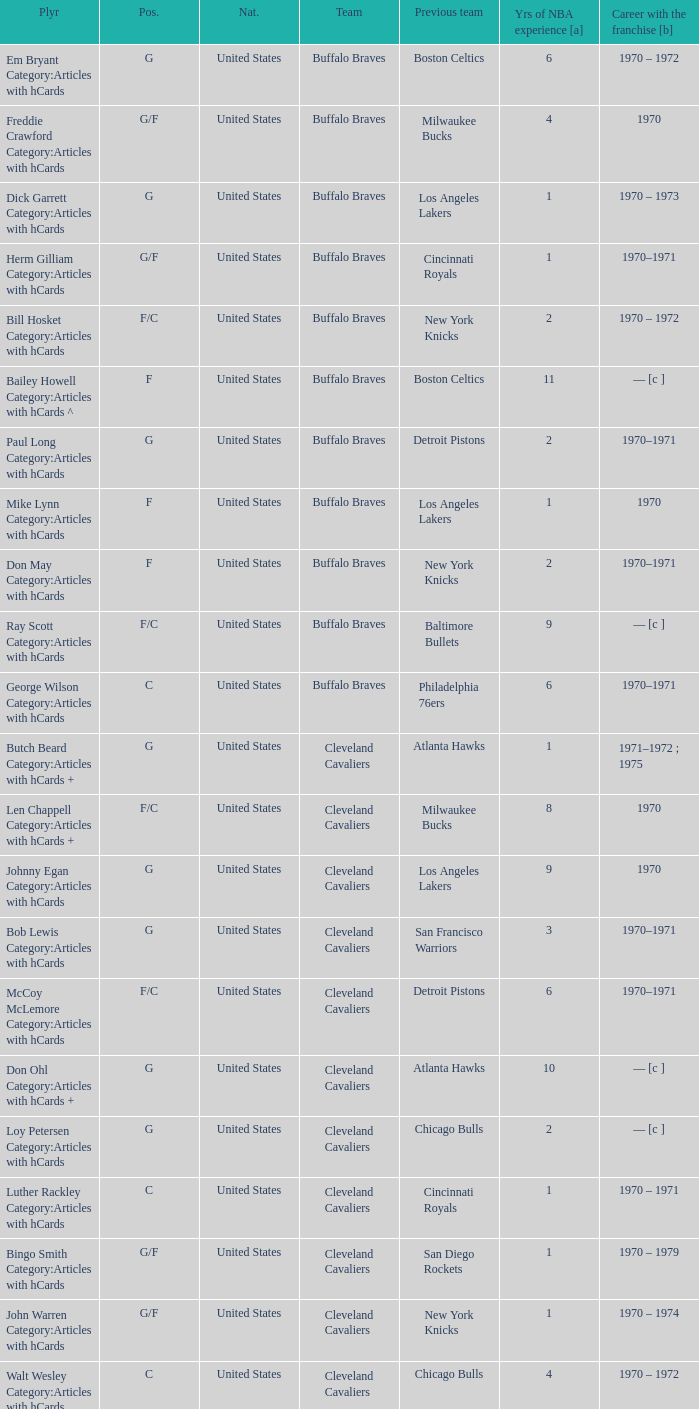Who is the player with 7 years of NBA experience? Larry Siegfried Category:Articles with hCards. 